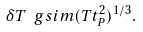<formula> <loc_0><loc_0><loc_500><loc_500>\delta T \ g s i m ( T t _ { P } ^ { 2 } ) ^ { 1 / 3 } .</formula> 